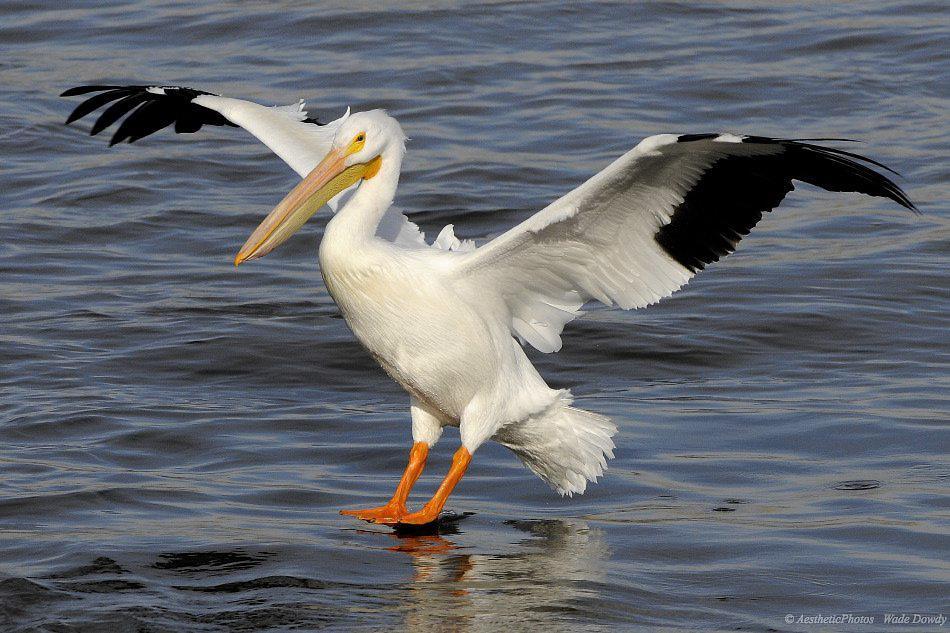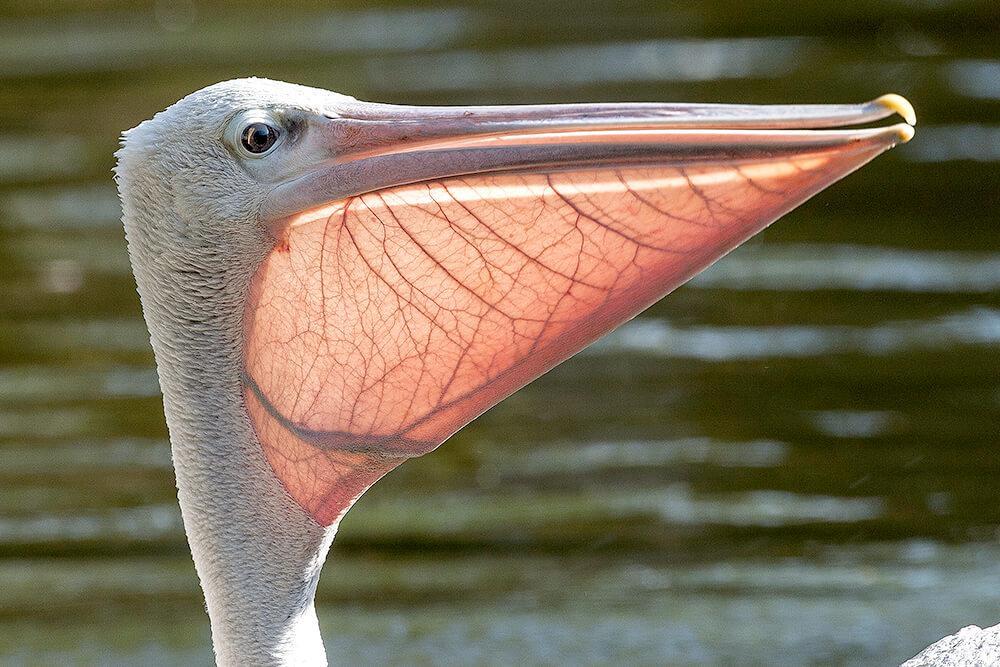The first image is the image on the left, the second image is the image on the right. Given the left and right images, does the statement "One of the birds has its wings spread." hold true? Answer yes or no. Yes. 